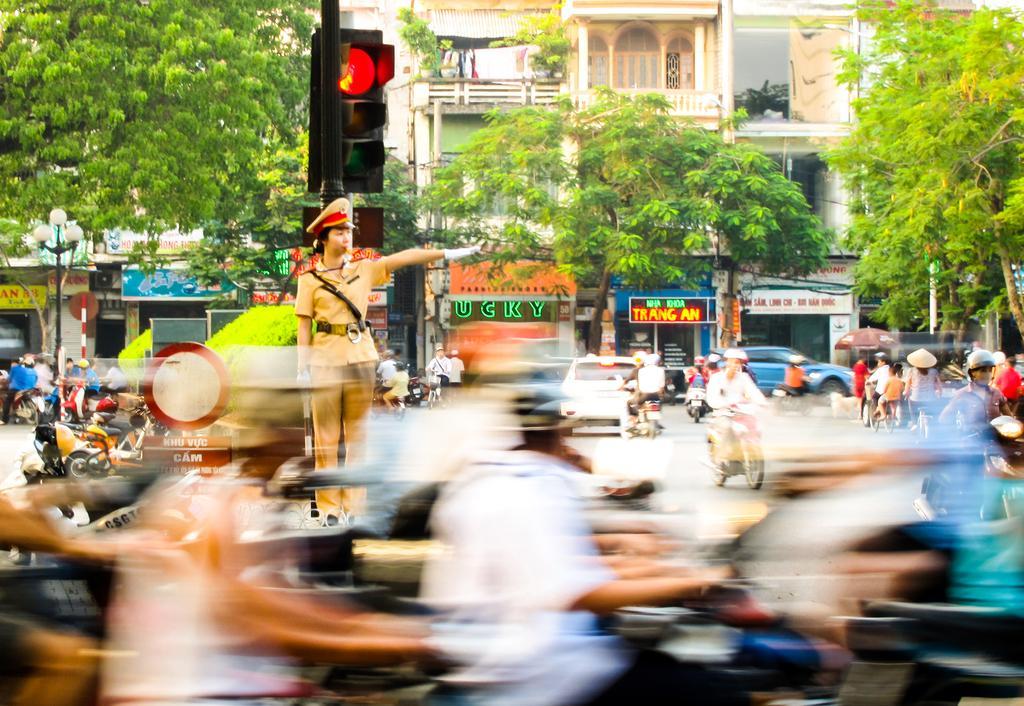Describe this image in one or two sentences. On the left side, there is a person in a uniform, stretching his hand and standing. Beside her, there are signal lights attached to a pole. In front of her, there are persons driving vehicles. In the background, there are vehicles, there are trees and there are buildings. 